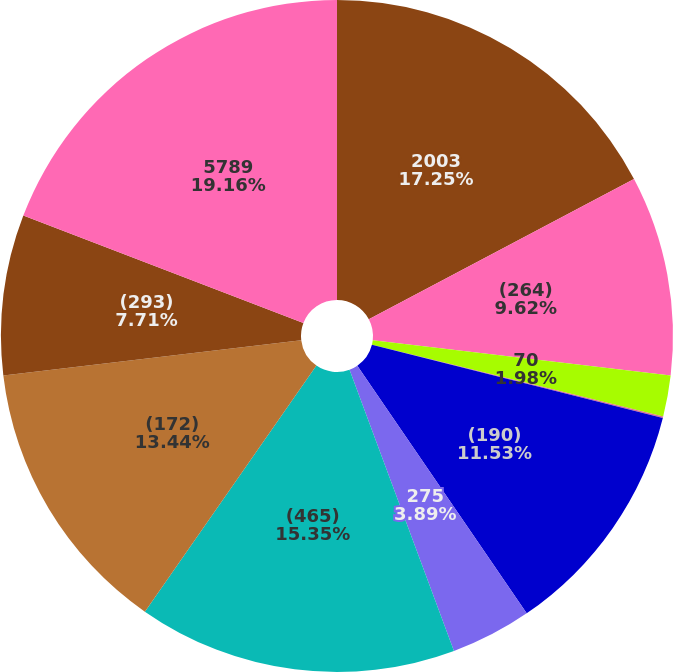<chart> <loc_0><loc_0><loc_500><loc_500><pie_chart><fcel>2003<fcel>(264)<fcel>70<fcel>-<fcel>(190)<fcel>275<fcel>(465)<fcel>(172)<fcel>(293)<fcel>5789<nl><fcel>17.26%<fcel>9.62%<fcel>1.98%<fcel>0.07%<fcel>11.53%<fcel>3.89%<fcel>15.35%<fcel>13.44%<fcel>7.71%<fcel>19.17%<nl></chart> 